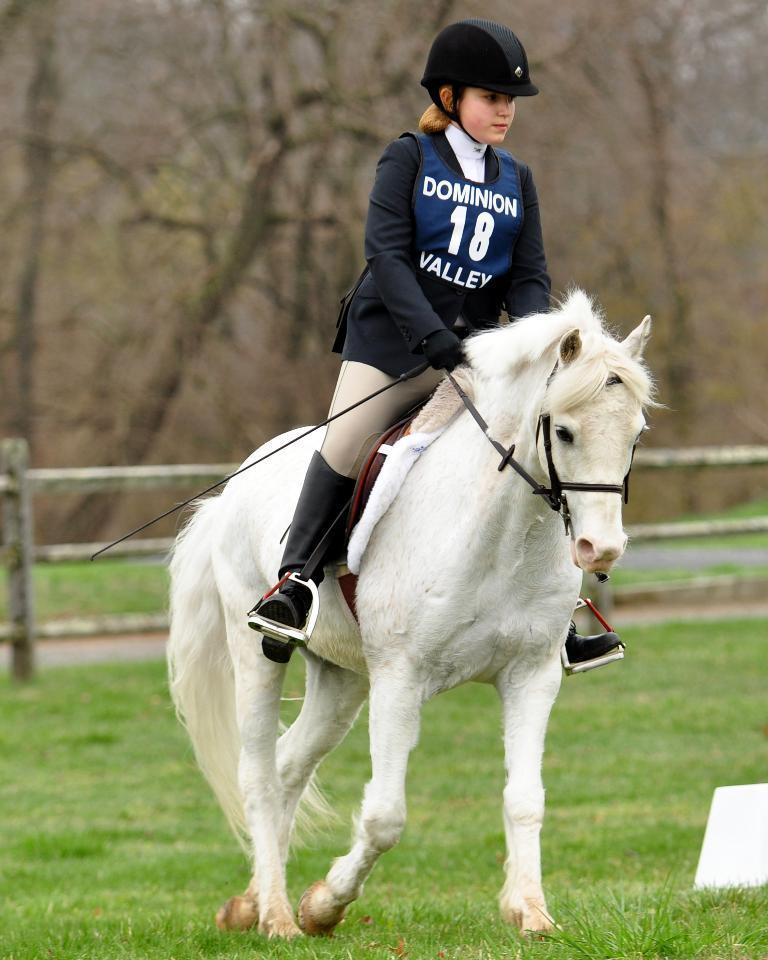Can you describe this image briefly? Woman is sitting on a horse. Land is covered with grass. Background it is blur. We can bare trees and fence. 